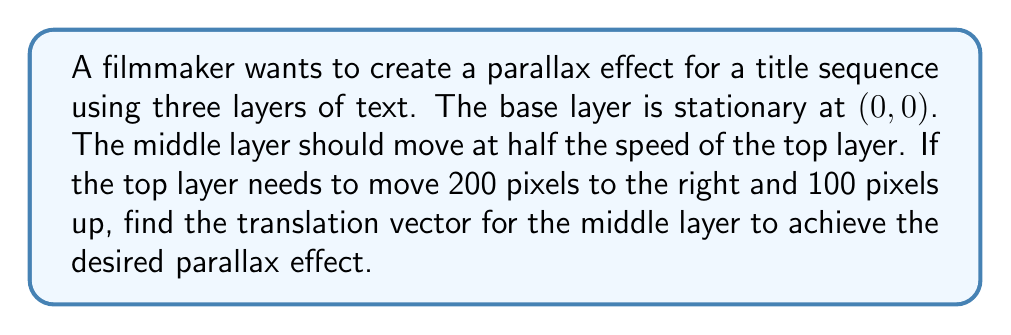Help me with this question. To solve this problem, we need to understand the concept of parallax and how it relates to function transformations:

1) Parallax effect: Objects closer to the viewer appear to move faster than objects farther away when the viewer's position changes.

2) In this case, we have three layers:
   - Base layer (farthest): Stationary at $(0,0)$
   - Middle layer: Moves at half the speed of the top layer
   - Top layer (closest): Moves 200 pixels right and 100 pixels up

3) The movement of the top layer can be represented as a translation vector:
   $$\vec{v}_\text{top} = \begin{pmatrix} 200 \\ 100 \end{pmatrix}$$

4) Since the middle layer moves at half the speed, its translation vector will be half of the top layer's vector:
   $$\vec{v}_\text{middle} = \frac{1}{2} \vec{v}_\text{top} = \frac{1}{2} \begin{pmatrix} 200 \\ 100 \end{pmatrix}$$

5) Calculating the components of the middle layer's vector:
   $$\vec{v}_\text{middle} = \begin{pmatrix} 200/2 \\ 100/2 \end{pmatrix} = \begin{pmatrix} 100 \\ 50 \end{pmatrix}$$

Therefore, the translation vector for the middle layer is $(100, 50)$.
Answer: The translation vector for the middle layer is $(100, 50)$. 